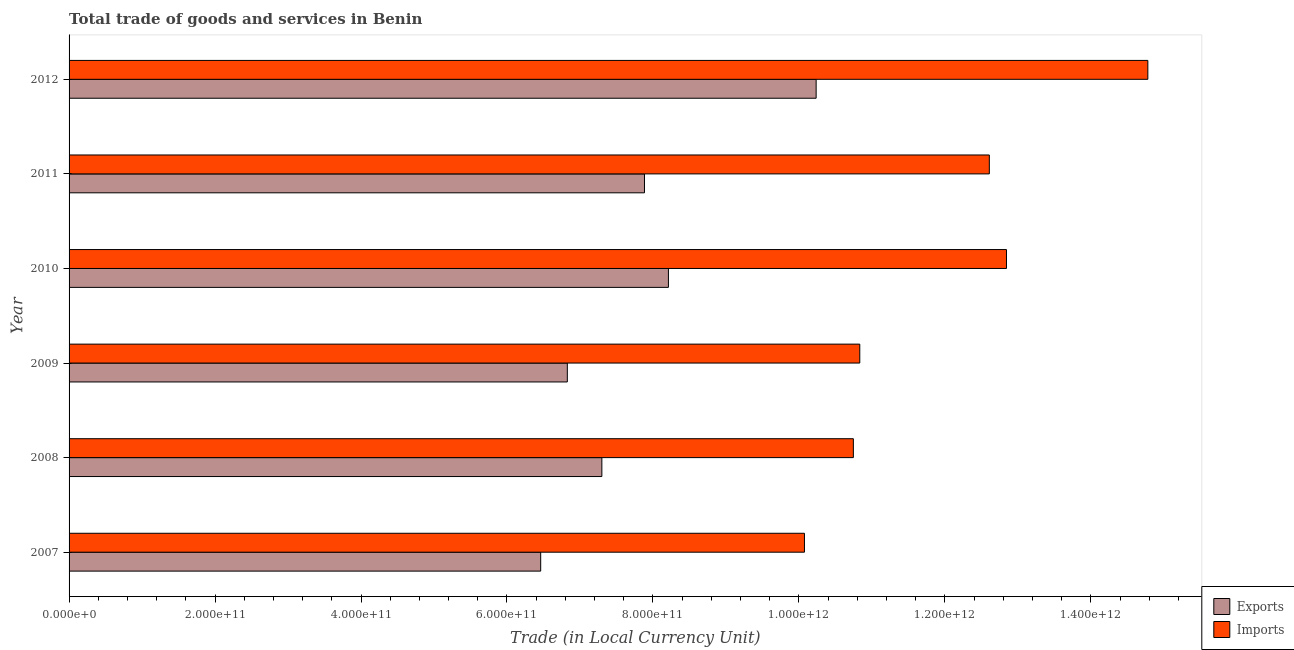How many different coloured bars are there?
Make the answer very short. 2. How many groups of bars are there?
Keep it short and to the point. 6. Are the number of bars on each tick of the Y-axis equal?
Give a very brief answer. Yes. How many bars are there on the 4th tick from the top?
Offer a very short reply. 2. What is the imports of goods and services in 2008?
Offer a terse response. 1.07e+12. Across all years, what is the maximum export of goods and services?
Your answer should be compact. 1.02e+12. Across all years, what is the minimum export of goods and services?
Your response must be concise. 6.46e+11. In which year was the imports of goods and services minimum?
Your answer should be compact. 2007. What is the total imports of goods and services in the graph?
Your response must be concise. 7.19e+12. What is the difference between the export of goods and services in 2010 and that in 2012?
Offer a very short reply. -2.02e+11. What is the difference between the imports of goods and services in 2011 and the export of goods and services in 2012?
Your response must be concise. 2.37e+11. What is the average imports of goods and services per year?
Ensure brevity in your answer.  1.20e+12. In the year 2011, what is the difference between the export of goods and services and imports of goods and services?
Your answer should be very brief. -4.72e+11. In how many years, is the export of goods and services greater than 960000000000 LCU?
Offer a terse response. 1. What is the ratio of the export of goods and services in 2009 to that in 2011?
Make the answer very short. 0.87. What is the difference between the highest and the second highest export of goods and services?
Offer a very short reply. 2.02e+11. What is the difference between the highest and the lowest export of goods and services?
Ensure brevity in your answer.  3.77e+11. In how many years, is the export of goods and services greater than the average export of goods and services taken over all years?
Offer a terse response. 3. Is the sum of the export of goods and services in 2007 and 2008 greater than the maximum imports of goods and services across all years?
Make the answer very short. No. What does the 1st bar from the top in 2008 represents?
Provide a succinct answer. Imports. What does the 2nd bar from the bottom in 2008 represents?
Provide a succinct answer. Imports. How many bars are there?
Provide a succinct answer. 12. Are all the bars in the graph horizontal?
Your response must be concise. Yes. What is the difference between two consecutive major ticks on the X-axis?
Your response must be concise. 2.00e+11. Are the values on the major ticks of X-axis written in scientific E-notation?
Your answer should be compact. Yes. Does the graph contain any zero values?
Your answer should be compact. No. Does the graph contain grids?
Give a very brief answer. No. How are the legend labels stacked?
Provide a succinct answer. Vertical. What is the title of the graph?
Your answer should be compact. Total trade of goods and services in Benin. What is the label or title of the X-axis?
Provide a short and direct response. Trade (in Local Currency Unit). What is the label or title of the Y-axis?
Your answer should be very brief. Year. What is the Trade (in Local Currency Unit) of Exports in 2007?
Make the answer very short. 6.46e+11. What is the Trade (in Local Currency Unit) in Imports in 2007?
Make the answer very short. 1.01e+12. What is the Trade (in Local Currency Unit) in Exports in 2008?
Keep it short and to the point. 7.30e+11. What is the Trade (in Local Currency Unit) in Imports in 2008?
Provide a succinct answer. 1.07e+12. What is the Trade (in Local Currency Unit) in Exports in 2009?
Offer a very short reply. 6.83e+11. What is the Trade (in Local Currency Unit) in Imports in 2009?
Make the answer very short. 1.08e+12. What is the Trade (in Local Currency Unit) in Exports in 2010?
Give a very brief answer. 8.21e+11. What is the Trade (in Local Currency Unit) in Imports in 2010?
Make the answer very short. 1.28e+12. What is the Trade (in Local Currency Unit) in Exports in 2011?
Offer a terse response. 7.88e+11. What is the Trade (in Local Currency Unit) of Imports in 2011?
Provide a short and direct response. 1.26e+12. What is the Trade (in Local Currency Unit) in Exports in 2012?
Your answer should be very brief. 1.02e+12. What is the Trade (in Local Currency Unit) of Imports in 2012?
Your answer should be very brief. 1.48e+12. Across all years, what is the maximum Trade (in Local Currency Unit) in Exports?
Your answer should be very brief. 1.02e+12. Across all years, what is the maximum Trade (in Local Currency Unit) in Imports?
Offer a terse response. 1.48e+12. Across all years, what is the minimum Trade (in Local Currency Unit) in Exports?
Your response must be concise. 6.46e+11. Across all years, what is the minimum Trade (in Local Currency Unit) of Imports?
Ensure brevity in your answer.  1.01e+12. What is the total Trade (in Local Currency Unit) in Exports in the graph?
Make the answer very short. 4.69e+12. What is the total Trade (in Local Currency Unit) of Imports in the graph?
Provide a succinct answer. 7.19e+12. What is the difference between the Trade (in Local Currency Unit) in Exports in 2007 and that in 2008?
Keep it short and to the point. -8.38e+1. What is the difference between the Trade (in Local Currency Unit) of Imports in 2007 and that in 2008?
Make the answer very short. -6.70e+1. What is the difference between the Trade (in Local Currency Unit) in Exports in 2007 and that in 2009?
Ensure brevity in your answer.  -3.65e+1. What is the difference between the Trade (in Local Currency Unit) of Imports in 2007 and that in 2009?
Your answer should be compact. -7.58e+1. What is the difference between the Trade (in Local Currency Unit) in Exports in 2007 and that in 2010?
Keep it short and to the point. -1.75e+11. What is the difference between the Trade (in Local Currency Unit) of Imports in 2007 and that in 2010?
Keep it short and to the point. -2.77e+11. What is the difference between the Trade (in Local Currency Unit) in Exports in 2007 and that in 2011?
Keep it short and to the point. -1.42e+11. What is the difference between the Trade (in Local Currency Unit) of Imports in 2007 and that in 2011?
Keep it short and to the point. -2.53e+11. What is the difference between the Trade (in Local Currency Unit) of Exports in 2007 and that in 2012?
Make the answer very short. -3.77e+11. What is the difference between the Trade (in Local Currency Unit) of Imports in 2007 and that in 2012?
Provide a short and direct response. -4.70e+11. What is the difference between the Trade (in Local Currency Unit) of Exports in 2008 and that in 2009?
Give a very brief answer. 4.73e+1. What is the difference between the Trade (in Local Currency Unit) of Imports in 2008 and that in 2009?
Your response must be concise. -8.80e+09. What is the difference between the Trade (in Local Currency Unit) in Exports in 2008 and that in 2010?
Provide a short and direct response. -9.12e+1. What is the difference between the Trade (in Local Currency Unit) of Imports in 2008 and that in 2010?
Your answer should be very brief. -2.10e+11. What is the difference between the Trade (in Local Currency Unit) of Exports in 2008 and that in 2011?
Keep it short and to the point. -5.84e+1. What is the difference between the Trade (in Local Currency Unit) of Imports in 2008 and that in 2011?
Provide a short and direct response. -1.86e+11. What is the difference between the Trade (in Local Currency Unit) of Exports in 2008 and that in 2012?
Provide a short and direct response. -2.94e+11. What is the difference between the Trade (in Local Currency Unit) of Imports in 2008 and that in 2012?
Ensure brevity in your answer.  -4.04e+11. What is the difference between the Trade (in Local Currency Unit) of Exports in 2009 and that in 2010?
Ensure brevity in your answer.  -1.38e+11. What is the difference between the Trade (in Local Currency Unit) in Imports in 2009 and that in 2010?
Your answer should be compact. -2.01e+11. What is the difference between the Trade (in Local Currency Unit) in Exports in 2009 and that in 2011?
Your answer should be compact. -1.06e+11. What is the difference between the Trade (in Local Currency Unit) of Imports in 2009 and that in 2011?
Provide a succinct answer. -1.78e+11. What is the difference between the Trade (in Local Currency Unit) of Exports in 2009 and that in 2012?
Give a very brief answer. -3.41e+11. What is the difference between the Trade (in Local Currency Unit) of Imports in 2009 and that in 2012?
Your answer should be very brief. -3.95e+11. What is the difference between the Trade (in Local Currency Unit) in Exports in 2010 and that in 2011?
Provide a short and direct response. 3.28e+1. What is the difference between the Trade (in Local Currency Unit) of Imports in 2010 and that in 2011?
Your answer should be very brief. 2.35e+1. What is the difference between the Trade (in Local Currency Unit) in Exports in 2010 and that in 2012?
Give a very brief answer. -2.02e+11. What is the difference between the Trade (in Local Currency Unit) of Imports in 2010 and that in 2012?
Offer a very short reply. -1.94e+11. What is the difference between the Trade (in Local Currency Unit) in Exports in 2011 and that in 2012?
Your answer should be compact. -2.35e+11. What is the difference between the Trade (in Local Currency Unit) in Imports in 2011 and that in 2012?
Keep it short and to the point. -2.17e+11. What is the difference between the Trade (in Local Currency Unit) in Exports in 2007 and the Trade (in Local Currency Unit) in Imports in 2008?
Give a very brief answer. -4.28e+11. What is the difference between the Trade (in Local Currency Unit) in Exports in 2007 and the Trade (in Local Currency Unit) in Imports in 2009?
Ensure brevity in your answer.  -4.37e+11. What is the difference between the Trade (in Local Currency Unit) of Exports in 2007 and the Trade (in Local Currency Unit) of Imports in 2010?
Your response must be concise. -6.38e+11. What is the difference between the Trade (in Local Currency Unit) of Exports in 2007 and the Trade (in Local Currency Unit) of Imports in 2011?
Provide a succinct answer. -6.15e+11. What is the difference between the Trade (in Local Currency Unit) in Exports in 2007 and the Trade (in Local Currency Unit) in Imports in 2012?
Your answer should be very brief. -8.32e+11. What is the difference between the Trade (in Local Currency Unit) in Exports in 2008 and the Trade (in Local Currency Unit) in Imports in 2009?
Your answer should be compact. -3.53e+11. What is the difference between the Trade (in Local Currency Unit) in Exports in 2008 and the Trade (in Local Currency Unit) in Imports in 2010?
Your answer should be very brief. -5.54e+11. What is the difference between the Trade (in Local Currency Unit) of Exports in 2008 and the Trade (in Local Currency Unit) of Imports in 2011?
Offer a very short reply. -5.31e+11. What is the difference between the Trade (in Local Currency Unit) in Exports in 2008 and the Trade (in Local Currency Unit) in Imports in 2012?
Offer a very short reply. -7.48e+11. What is the difference between the Trade (in Local Currency Unit) of Exports in 2009 and the Trade (in Local Currency Unit) of Imports in 2010?
Your answer should be very brief. -6.02e+11. What is the difference between the Trade (in Local Currency Unit) in Exports in 2009 and the Trade (in Local Currency Unit) in Imports in 2011?
Make the answer very short. -5.78e+11. What is the difference between the Trade (in Local Currency Unit) of Exports in 2009 and the Trade (in Local Currency Unit) of Imports in 2012?
Provide a short and direct response. -7.95e+11. What is the difference between the Trade (in Local Currency Unit) of Exports in 2010 and the Trade (in Local Currency Unit) of Imports in 2011?
Ensure brevity in your answer.  -4.40e+11. What is the difference between the Trade (in Local Currency Unit) in Exports in 2010 and the Trade (in Local Currency Unit) in Imports in 2012?
Provide a short and direct response. -6.57e+11. What is the difference between the Trade (in Local Currency Unit) in Exports in 2011 and the Trade (in Local Currency Unit) in Imports in 2012?
Your response must be concise. -6.90e+11. What is the average Trade (in Local Currency Unit) of Exports per year?
Your answer should be compact. 7.82e+11. What is the average Trade (in Local Currency Unit) in Imports per year?
Offer a terse response. 1.20e+12. In the year 2007, what is the difference between the Trade (in Local Currency Unit) of Exports and Trade (in Local Currency Unit) of Imports?
Your response must be concise. -3.61e+11. In the year 2008, what is the difference between the Trade (in Local Currency Unit) of Exports and Trade (in Local Currency Unit) of Imports?
Ensure brevity in your answer.  -3.45e+11. In the year 2009, what is the difference between the Trade (in Local Currency Unit) of Exports and Trade (in Local Currency Unit) of Imports?
Provide a short and direct response. -4.01e+11. In the year 2010, what is the difference between the Trade (in Local Currency Unit) of Exports and Trade (in Local Currency Unit) of Imports?
Give a very brief answer. -4.63e+11. In the year 2011, what is the difference between the Trade (in Local Currency Unit) in Exports and Trade (in Local Currency Unit) in Imports?
Provide a short and direct response. -4.72e+11. In the year 2012, what is the difference between the Trade (in Local Currency Unit) in Exports and Trade (in Local Currency Unit) in Imports?
Offer a terse response. -4.54e+11. What is the ratio of the Trade (in Local Currency Unit) of Exports in 2007 to that in 2008?
Ensure brevity in your answer.  0.89. What is the ratio of the Trade (in Local Currency Unit) in Imports in 2007 to that in 2008?
Offer a terse response. 0.94. What is the ratio of the Trade (in Local Currency Unit) in Exports in 2007 to that in 2009?
Make the answer very short. 0.95. What is the ratio of the Trade (in Local Currency Unit) in Exports in 2007 to that in 2010?
Offer a terse response. 0.79. What is the ratio of the Trade (in Local Currency Unit) of Imports in 2007 to that in 2010?
Your answer should be very brief. 0.78. What is the ratio of the Trade (in Local Currency Unit) of Exports in 2007 to that in 2011?
Provide a succinct answer. 0.82. What is the ratio of the Trade (in Local Currency Unit) of Imports in 2007 to that in 2011?
Your answer should be very brief. 0.8. What is the ratio of the Trade (in Local Currency Unit) of Exports in 2007 to that in 2012?
Make the answer very short. 0.63. What is the ratio of the Trade (in Local Currency Unit) in Imports in 2007 to that in 2012?
Your answer should be compact. 0.68. What is the ratio of the Trade (in Local Currency Unit) of Exports in 2008 to that in 2009?
Your answer should be very brief. 1.07. What is the ratio of the Trade (in Local Currency Unit) of Imports in 2008 to that in 2009?
Your answer should be very brief. 0.99. What is the ratio of the Trade (in Local Currency Unit) of Exports in 2008 to that in 2010?
Make the answer very short. 0.89. What is the ratio of the Trade (in Local Currency Unit) in Imports in 2008 to that in 2010?
Provide a succinct answer. 0.84. What is the ratio of the Trade (in Local Currency Unit) in Exports in 2008 to that in 2011?
Your answer should be compact. 0.93. What is the ratio of the Trade (in Local Currency Unit) in Imports in 2008 to that in 2011?
Provide a short and direct response. 0.85. What is the ratio of the Trade (in Local Currency Unit) in Exports in 2008 to that in 2012?
Offer a very short reply. 0.71. What is the ratio of the Trade (in Local Currency Unit) of Imports in 2008 to that in 2012?
Your response must be concise. 0.73. What is the ratio of the Trade (in Local Currency Unit) of Exports in 2009 to that in 2010?
Ensure brevity in your answer.  0.83. What is the ratio of the Trade (in Local Currency Unit) of Imports in 2009 to that in 2010?
Ensure brevity in your answer.  0.84. What is the ratio of the Trade (in Local Currency Unit) in Exports in 2009 to that in 2011?
Your answer should be compact. 0.87. What is the ratio of the Trade (in Local Currency Unit) in Imports in 2009 to that in 2011?
Give a very brief answer. 0.86. What is the ratio of the Trade (in Local Currency Unit) in Exports in 2009 to that in 2012?
Ensure brevity in your answer.  0.67. What is the ratio of the Trade (in Local Currency Unit) in Imports in 2009 to that in 2012?
Make the answer very short. 0.73. What is the ratio of the Trade (in Local Currency Unit) in Exports in 2010 to that in 2011?
Ensure brevity in your answer.  1.04. What is the ratio of the Trade (in Local Currency Unit) of Imports in 2010 to that in 2011?
Offer a terse response. 1.02. What is the ratio of the Trade (in Local Currency Unit) in Exports in 2010 to that in 2012?
Give a very brief answer. 0.8. What is the ratio of the Trade (in Local Currency Unit) in Imports in 2010 to that in 2012?
Keep it short and to the point. 0.87. What is the ratio of the Trade (in Local Currency Unit) of Exports in 2011 to that in 2012?
Make the answer very short. 0.77. What is the ratio of the Trade (in Local Currency Unit) in Imports in 2011 to that in 2012?
Your answer should be compact. 0.85. What is the difference between the highest and the second highest Trade (in Local Currency Unit) of Exports?
Your answer should be very brief. 2.02e+11. What is the difference between the highest and the second highest Trade (in Local Currency Unit) in Imports?
Offer a very short reply. 1.94e+11. What is the difference between the highest and the lowest Trade (in Local Currency Unit) of Exports?
Offer a very short reply. 3.77e+11. What is the difference between the highest and the lowest Trade (in Local Currency Unit) in Imports?
Make the answer very short. 4.70e+11. 